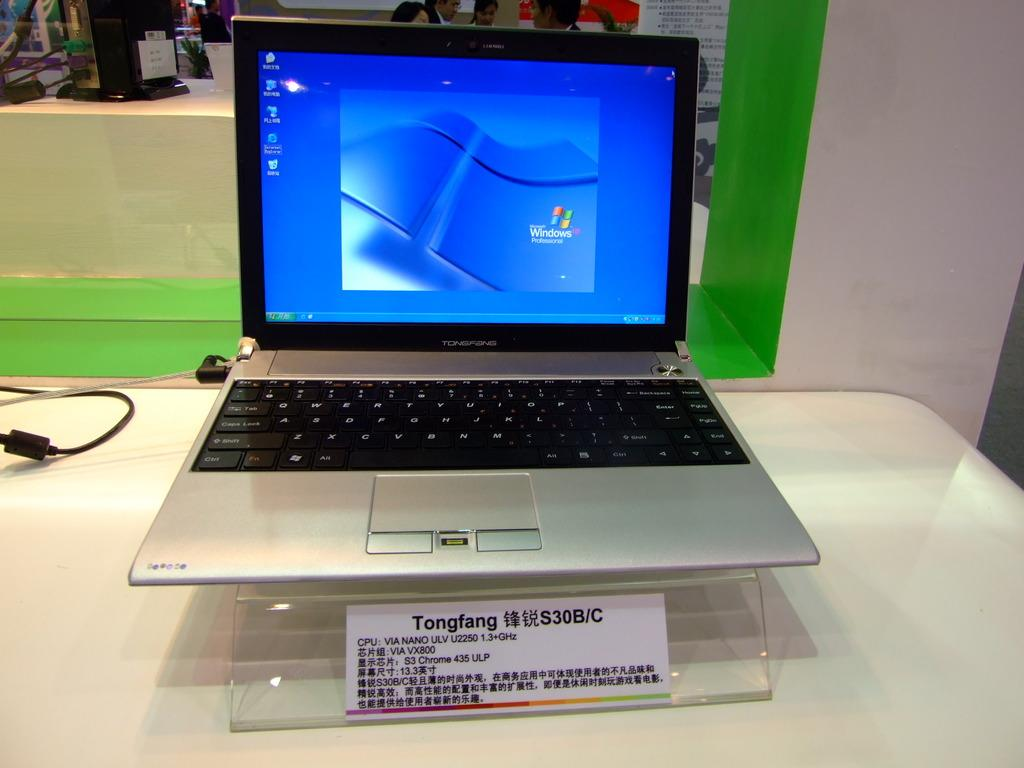<image>
Provide a brief description of the given image. A tonfang laptop computer that has the screen open. 